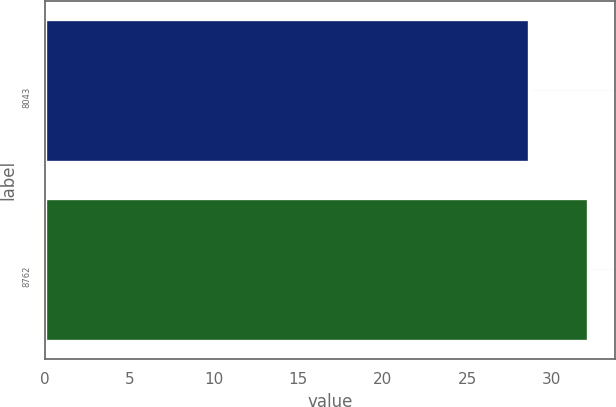<chart> <loc_0><loc_0><loc_500><loc_500><bar_chart><fcel>8043<fcel>8762<nl><fcel>28.65<fcel>32.13<nl></chart> 